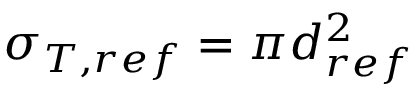<formula> <loc_0><loc_0><loc_500><loc_500>\sigma _ { T , r e f } = \pi d _ { r e f } ^ { 2 }</formula> 